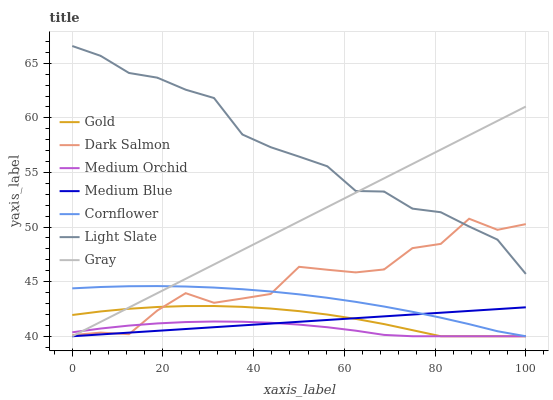Does Medium Orchid have the minimum area under the curve?
Answer yes or no. Yes. Does Light Slate have the maximum area under the curve?
Answer yes or no. Yes. Does Gold have the minimum area under the curve?
Answer yes or no. No. Does Gold have the maximum area under the curve?
Answer yes or no. No. Is Medium Blue the smoothest?
Answer yes or no. Yes. Is Dark Salmon the roughest?
Answer yes or no. Yes. Is Gold the smoothest?
Answer yes or no. No. Is Gold the roughest?
Answer yes or no. No. Does Cornflower have the lowest value?
Answer yes or no. Yes. Does Light Slate have the lowest value?
Answer yes or no. No. Does Light Slate have the highest value?
Answer yes or no. Yes. Does Gold have the highest value?
Answer yes or no. No. Is Medium Blue less than Light Slate?
Answer yes or no. Yes. Is Light Slate greater than Medium Blue?
Answer yes or no. Yes. Does Gray intersect Gold?
Answer yes or no. Yes. Is Gray less than Gold?
Answer yes or no. No. Is Gray greater than Gold?
Answer yes or no. No. Does Medium Blue intersect Light Slate?
Answer yes or no. No. 